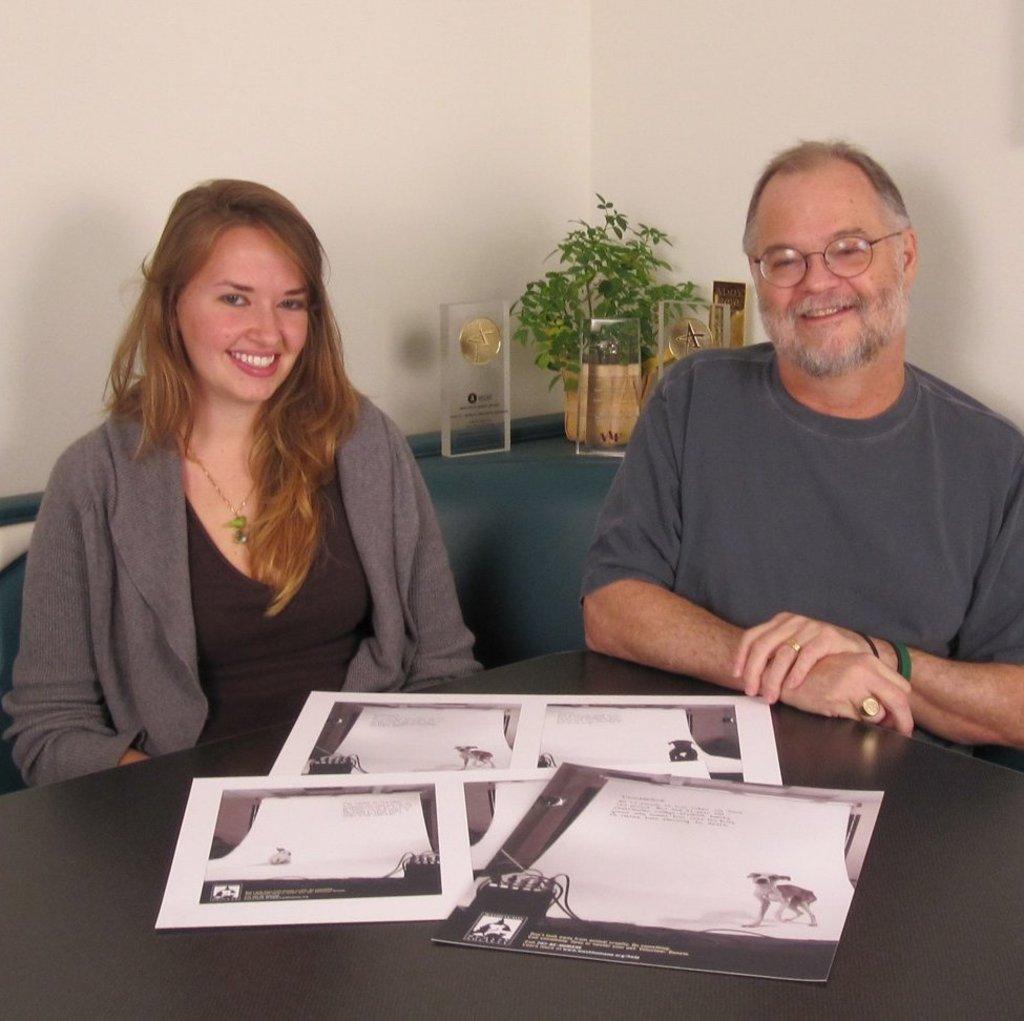In one or two sentences, can you explain what this image depicts? In this picture there are two people sitting on the table and papers are on top of the table. In the background we observe a flower pot, a moment and few awards kept on the blue table. 